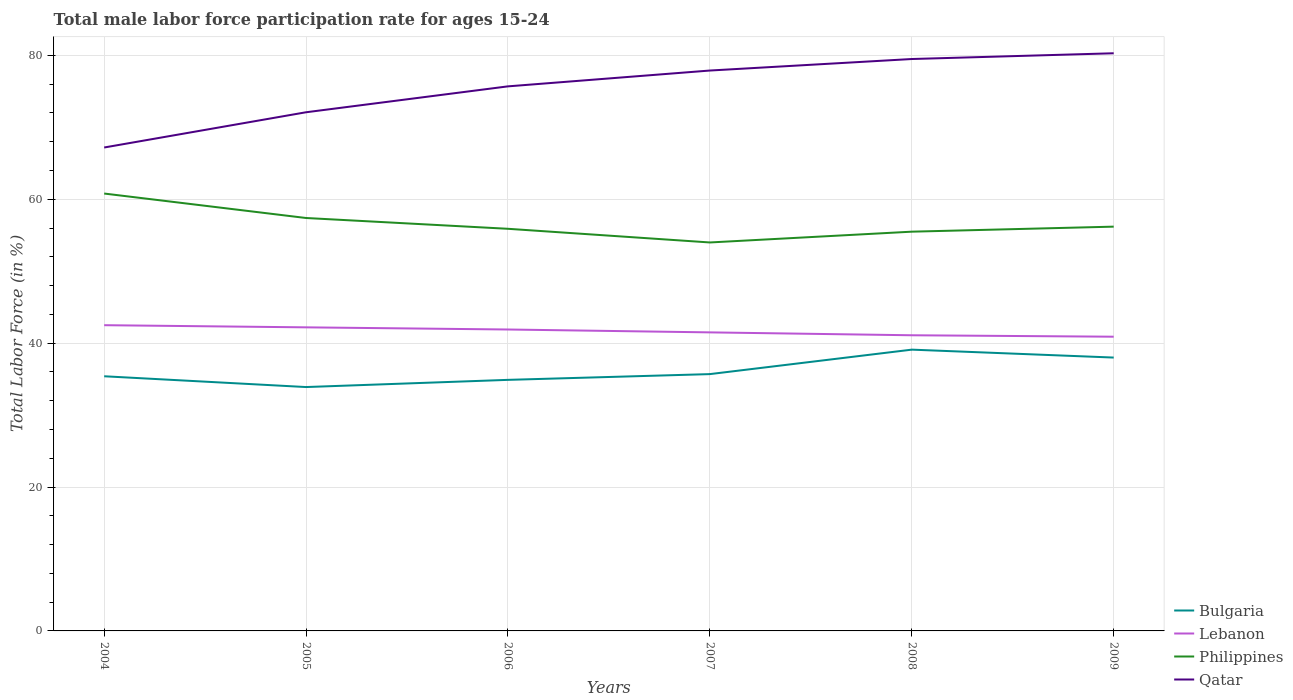Is the number of lines equal to the number of legend labels?
Ensure brevity in your answer.  Yes. Across all years, what is the maximum male labor force participation rate in Lebanon?
Provide a succinct answer. 40.9. In which year was the male labor force participation rate in Philippines maximum?
Give a very brief answer. 2007. What is the total male labor force participation rate in Lebanon in the graph?
Offer a terse response. 1.6. What is the difference between the highest and the second highest male labor force participation rate in Bulgaria?
Offer a very short reply. 5.2. How many years are there in the graph?
Your response must be concise. 6. Does the graph contain grids?
Your answer should be very brief. Yes. Where does the legend appear in the graph?
Provide a short and direct response. Bottom right. How many legend labels are there?
Make the answer very short. 4. What is the title of the graph?
Provide a succinct answer. Total male labor force participation rate for ages 15-24. What is the label or title of the X-axis?
Your answer should be very brief. Years. What is the label or title of the Y-axis?
Provide a succinct answer. Total Labor Force (in %). What is the Total Labor Force (in %) of Bulgaria in 2004?
Offer a terse response. 35.4. What is the Total Labor Force (in %) of Lebanon in 2004?
Ensure brevity in your answer.  42.5. What is the Total Labor Force (in %) in Philippines in 2004?
Offer a terse response. 60.8. What is the Total Labor Force (in %) of Qatar in 2004?
Offer a very short reply. 67.2. What is the Total Labor Force (in %) in Bulgaria in 2005?
Give a very brief answer. 33.9. What is the Total Labor Force (in %) in Lebanon in 2005?
Your answer should be compact. 42.2. What is the Total Labor Force (in %) in Philippines in 2005?
Make the answer very short. 57.4. What is the Total Labor Force (in %) of Qatar in 2005?
Ensure brevity in your answer.  72.1. What is the Total Labor Force (in %) in Bulgaria in 2006?
Offer a terse response. 34.9. What is the Total Labor Force (in %) in Lebanon in 2006?
Provide a succinct answer. 41.9. What is the Total Labor Force (in %) in Philippines in 2006?
Keep it short and to the point. 55.9. What is the Total Labor Force (in %) in Qatar in 2006?
Give a very brief answer. 75.7. What is the Total Labor Force (in %) in Bulgaria in 2007?
Your answer should be very brief. 35.7. What is the Total Labor Force (in %) in Lebanon in 2007?
Provide a succinct answer. 41.5. What is the Total Labor Force (in %) of Qatar in 2007?
Provide a short and direct response. 77.9. What is the Total Labor Force (in %) in Bulgaria in 2008?
Offer a terse response. 39.1. What is the Total Labor Force (in %) of Lebanon in 2008?
Your answer should be very brief. 41.1. What is the Total Labor Force (in %) of Philippines in 2008?
Provide a short and direct response. 55.5. What is the Total Labor Force (in %) of Qatar in 2008?
Provide a short and direct response. 79.5. What is the Total Labor Force (in %) of Bulgaria in 2009?
Ensure brevity in your answer.  38. What is the Total Labor Force (in %) of Lebanon in 2009?
Provide a short and direct response. 40.9. What is the Total Labor Force (in %) of Philippines in 2009?
Make the answer very short. 56.2. What is the Total Labor Force (in %) in Qatar in 2009?
Your response must be concise. 80.3. Across all years, what is the maximum Total Labor Force (in %) of Bulgaria?
Provide a succinct answer. 39.1. Across all years, what is the maximum Total Labor Force (in %) in Lebanon?
Provide a succinct answer. 42.5. Across all years, what is the maximum Total Labor Force (in %) of Philippines?
Your response must be concise. 60.8. Across all years, what is the maximum Total Labor Force (in %) of Qatar?
Give a very brief answer. 80.3. Across all years, what is the minimum Total Labor Force (in %) of Bulgaria?
Keep it short and to the point. 33.9. Across all years, what is the minimum Total Labor Force (in %) in Lebanon?
Ensure brevity in your answer.  40.9. Across all years, what is the minimum Total Labor Force (in %) of Qatar?
Keep it short and to the point. 67.2. What is the total Total Labor Force (in %) in Bulgaria in the graph?
Provide a succinct answer. 217. What is the total Total Labor Force (in %) of Lebanon in the graph?
Offer a very short reply. 250.1. What is the total Total Labor Force (in %) of Philippines in the graph?
Offer a terse response. 339.8. What is the total Total Labor Force (in %) in Qatar in the graph?
Give a very brief answer. 452.7. What is the difference between the Total Labor Force (in %) of Bulgaria in 2004 and that in 2005?
Give a very brief answer. 1.5. What is the difference between the Total Labor Force (in %) in Philippines in 2004 and that in 2005?
Offer a very short reply. 3.4. What is the difference between the Total Labor Force (in %) in Bulgaria in 2004 and that in 2006?
Provide a succinct answer. 0.5. What is the difference between the Total Labor Force (in %) in Lebanon in 2004 and that in 2006?
Your answer should be compact. 0.6. What is the difference between the Total Labor Force (in %) of Philippines in 2004 and that in 2006?
Your answer should be very brief. 4.9. What is the difference between the Total Labor Force (in %) in Lebanon in 2004 and that in 2007?
Provide a short and direct response. 1. What is the difference between the Total Labor Force (in %) of Philippines in 2004 and that in 2007?
Make the answer very short. 6.8. What is the difference between the Total Labor Force (in %) of Lebanon in 2004 and that in 2008?
Provide a succinct answer. 1.4. What is the difference between the Total Labor Force (in %) in Qatar in 2004 and that in 2008?
Ensure brevity in your answer.  -12.3. What is the difference between the Total Labor Force (in %) in Bulgaria in 2004 and that in 2009?
Your answer should be compact. -2.6. What is the difference between the Total Labor Force (in %) of Bulgaria in 2005 and that in 2006?
Keep it short and to the point. -1. What is the difference between the Total Labor Force (in %) of Qatar in 2005 and that in 2006?
Give a very brief answer. -3.6. What is the difference between the Total Labor Force (in %) in Bulgaria in 2005 and that in 2007?
Make the answer very short. -1.8. What is the difference between the Total Labor Force (in %) in Lebanon in 2005 and that in 2007?
Your response must be concise. 0.7. What is the difference between the Total Labor Force (in %) of Philippines in 2005 and that in 2007?
Your answer should be compact. 3.4. What is the difference between the Total Labor Force (in %) of Lebanon in 2005 and that in 2008?
Keep it short and to the point. 1.1. What is the difference between the Total Labor Force (in %) in Philippines in 2005 and that in 2008?
Keep it short and to the point. 1.9. What is the difference between the Total Labor Force (in %) of Philippines in 2005 and that in 2009?
Your response must be concise. 1.2. What is the difference between the Total Labor Force (in %) of Qatar in 2005 and that in 2009?
Make the answer very short. -8.2. What is the difference between the Total Labor Force (in %) of Bulgaria in 2006 and that in 2007?
Offer a very short reply. -0.8. What is the difference between the Total Labor Force (in %) of Philippines in 2006 and that in 2008?
Your answer should be very brief. 0.4. What is the difference between the Total Labor Force (in %) of Qatar in 2006 and that in 2008?
Give a very brief answer. -3.8. What is the difference between the Total Labor Force (in %) of Philippines in 2006 and that in 2009?
Your response must be concise. -0.3. What is the difference between the Total Labor Force (in %) in Qatar in 2006 and that in 2009?
Offer a terse response. -4.6. What is the difference between the Total Labor Force (in %) in Bulgaria in 2007 and that in 2008?
Provide a short and direct response. -3.4. What is the difference between the Total Labor Force (in %) in Lebanon in 2007 and that in 2008?
Make the answer very short. 0.4. What is the difference between the Total Labor Force (in %) in Bulgaria in 2007 and that in 2009?
Provide a short and direct response. -2.3. What is the difference between the Total Labor Force (in %) in Lebanon in 2007 and that in 2009?
Keep it short and to the point. 0.6. What is the difference between the Total Labor Force (in %) of Philippines in 2007 and that in 2009?
Give a very brief answer. -2.2. What is the difference between the Total Labor Force (in %) of Bulgaria in 2008 and that in 2009?
Make the answer very short. 1.1. What is the difference between the Total Labor Force (in %) in Philippines in 2008 and that in 2009?
Your answer should be compact. -0.7. What is the difference between the Total Labor Force (in %) in Bulgaria in 2004 and the Total Labor Force (in %) in Qatar in 2005?
Give a very brief answer. -36.7. What is the difference between the Total Labor Force (in %) in Lebanon in 2004 and the Total Labor Force (in %) in Philippines in 2005?
Keep it short and to the point. -14.9. What is the difference between the Total Labor Force (in %) of Lebanon in 2004 and the Total Labor Force (in %) of Qatar in 2005?
Make the answer very short. -29.6. What is the difference between the Total Labor Force (in %) in Philippines in 2004 and the Total Labor Force (in %) in Qatar in 2005?
Make the answer very short. -11.3. What is the difference between the Total Labor Force (in %) of Bulgaria in 2004 and the Total Labor Force (in %) of Philippines in 2006?
Your answer should be very brief. -20.5. What is the difference between the Total Labor Force (in %) in Bulgaria in 2004 and the Total Labor Force (in %) in Qatar in 2006?
Make the answer very short. -40.3. What is the difference between the Total Labor Force (in %) in Lebanon in 2004 and the Total Labor Force (in %) in Philippines in 2006?
Offer a very short reply. -13.4. What is the difference between the Total Labor Force (in %) of Lebanon in 2004 and the Total Labor Force (in %) of Qatar in 2006?
Provide a succinct answer. -33.2. What is the difference between the Total Labor Force (in %) of Philippines in 2004 and the Total Labor Force (in %) of Qatar in 2006?
Provide a short and direct response. -14.9. What is the difference between the Total Labor Force (in %) in Bulgaria in 2004 and the Total Labor Force (in %) in Philippines in 2007?
Keep it short and to the point. -18.6. What is the difference between the Total Labor Force (in %) of Bulgaria in 2004 and the Total Labor Force (in %) of Qatar in 2007?
Offer a very short reply. -42.5. What is the difference between the Total Labor Force (in %) in Lebanon in 2004 and the Total Labor Force (in %) in Philippines in 2007?
Offer a terse response. -11.5. What is the difference between the Total Labor Force (in %) of Lebanon in 2004 and the Total Labor Force (in %) of Qatar in 2007?
Offer a terse response. -35.4. What is the difference between the Total Labor Force (in %) of Philippines in 2004 and the Total Labor Force (in %) of Qatar in 2007?
Ensure brevity in your answer.  -17.1. What is the difference between the Total Labor Force (in %) of Bulgaria in 2004 and the Total Labor Force (in %) of Lebanon in 2008?
Offer a terse response. -5.7. What is the difference between the Total Labor Force (in %) in Bulgaria in 2004 and the Total Labor Force (in %) in Philippines in 2008?
Your answer should be compact. -20.1. What is the difference between the Total Labor Force (in %) of Bulgaria in 2004 and the Total Labor Force (in %) of Qatar in 2008?
Provide a succinct answer. -44.1. What is the difference between the Total Labor Force (in %) in Lebanon in 2004 and the Total Labor Force (in %) in Qatar in 2008?
Give a very brief answer. -37. What is the difference between the Total Labor Force (in %) in Philippines in 2004 and the Total Labor Force (in %) in Qatar in 2008?
Keep it short and to the point. -18.7. What is the difference between the Total Labor Force (in %) of Bulgaria in 2004 and the Total Labor Force (in %) of Lebanon in 2009?
Make the answer very short. -5.5. What is the difference between the Total Labor Force (in %) of Bulgaria in 2004 and the Total Labor Force (in %) of Philippines in 2009?
Make the answer very short. -20.8. What is the difference between the Total Labor Force (in %) of Bulgaria in 2004 and the Total Labor Force (in %) of Qatar in 2009?
Provide a succinct answer. -44.9. What is the difference between the Total Labor Force (in %) in Lebanon in 2004 and the Total Labor Force (in %) in Philippines in 2009?
Provide a succinct answer. -13.7. What is the difference between the Total Labor Force (in %) in Lebanon in 2004 and the Total Labor Force (in %) in Qatar in 2009?
Provide a succinct answer. -37.8. What is the difference between the Total Labor Force (in %) of Philippines in 2004 and the Total Labor Force (in %) of Qatar in 2009?
Offer a terse response. -19.5. What is the difference between the Total Labor Force (in %) in Bulgaria in 2005 and the Total Labor Force (in %) in Lebanon in 2006?
Offer a very short reply. -8. What is the difference between the Total Labor Force (in %) in Bulgaria in 2005 and the Total Labor Force (in %) in Philippines in 2006?
Your response must be concise. -22. What is the difference between the Total Labor Force (in %) in Bulgaria in 2005 and the Total Labor Force (in %) in Qatar in 2006?
Your answer should be very brief. -41.8. What is the difference between the Total Labor Force (in %) of Lebanon in 2005 and the Total Labor Force (in %) of Philippines in 2006?
Offer a very short reply. -13.7. What is the difference between the Total Labor Force (in %) in Lebanon in 2005 and the Total Labor Force (in %) in Qatar in 2006?
Provide a succinct answer. -33.5. What is the difference between the Total Labor Force (in %) of Philippines in 2005 and the Total Labor Force (in %) of Qatar in 2006?
Offer a terse response. -18.3. What is the difference between the Total Labor Force (in %) of Bulgaria in 2005 and the Total Labor Force (in %) of Philippines in 2007?
Give a very brief answer. -20.1. What is the difference between the Total Labor Force (in %) of Bulgaria in 2005 and the Total Labor Force (in %) of Qatar in 2007?
Ensure brevity in your answer.  -44. What is the difference between the Total Labor Force (in %) of Lebanon in 2005 and the Total Labor Force (in %) of Qatar in 2007?
Make the answer very short. -35.7. What is the difference between the Total Labor Force (in %) of Philippines in 2005 and the Total Labor Force (in %) of Qatar in 2007?
Offer a very short reply. -20.5. What is the difference between the Total Labor Force (in %) in Bulgaria in 2005 and the Total Labor Force (in %) in Lebanon in 2008?
Ensure brevity in your answer.  -7.2. What is the difference between the Total Labor Force (in %) in Bulgaria in 2005 and the Total Labor Force (in %) in Philippines in 2008?
Give a very brief answer. -21.6. What is the difference between the Total Labor Force (in %) of Bulgaria in 2005 and the Total Labor Force (in %) of Qatar in 2008?
Provide a short and direct response. -45.6. What is the difference between the Total Labor Force (in %) in Lebanon in 2005 and the Total Labor Force (in %) in Philippines in 2008?
Offer a terse response. -13.3. What is the difference between the Total Labor Force (in %) of Lebanon in 2005 and the Total Labor Force (in %) of Qatar in 2008?
Provide a short and direct response. -37.3. What is the difference between the Total Labor Force (in %) in Philippines in 2005 and the Total Labor Force (in %) in Qatar in 2008?
Provide a succinct answer. -22.1. What is the difference between the Total Labor Force (in %) in Bulgaria in 2005 and the Total Labor Force (in %) in Philippines in 2009?
Make the answer very short. -22.3. What is the difference between the Total Labor Force (in %) of Bulgaria in 2005 and the Total Labor Force (in %) of Qatar in 2009?
Provide a succinct answer. -46.4. What is the difference between the Total Labor Force (in %) in Lebanon in 2005 and the Total Labor Force (in %) in Qatar in 2009?
Offer a very short reply. -38.1. What is the difference between the Total Labor Force (in %) in Philippines in 2005 and the Total Labor Force (in %) in Qatar in 2009?
Offer a very short reply. -22.9. What is the difference between the Total Labor Force (in %) of Bulgaria in 2006 and the Total Labor Force (in %) of Lebanon in 2007?
Your response must be concise. -6.6. What is the difference between the Total Labor Force (in %) of Bulgaria in 2006 and the Total Labor Force (in %) of Philippines in 2007?
Offer a very short reply. -19.1. What is the difference between the Total Labor Force (in %) of Bulgaria in 2006 and the Total Labor Force (in %) of Qatar in 2007?
Your answer should be compact. -43. What is the difference between the Total Labor Force (in %) of Lebanon in 2006 and the Total Labor Force (in %) of Qatar in 2007?
Provide a short and direct response. -36. What is the difference between the Total Labor Force (in %) in Philippines in 2006 and the Total Labor Force (in %) in Qatar in 2007?
Your answer should be compact. -22. What is the difference between the Total Labor Force (in %) in Bulgaria in 2006 and the Total Labor Force (in %) in Philippines in 2008?
Offer a very short reply. -20.6. What is the difference between the Total Labor Force (in %) in Bulgaria in 2006 and the Total Labor Force (in %) in Qatar in 2008?
Provide a succinct answer. -44.6. What is the difference between the Total Labor Force (in %) in Lebanon in 2006 and the Total Labor Force (in %) in Philippines in 2008?
Keep it short and to the point. -13.6. What is the difference between the Total Labor Force (in %) of Lebanon in 2006 and the Total Labor Force (in %) of Qatar in 2008?
Your response must be concise. -37.6. What is the difference between the Total Labor Force (in %) in Philippines in 2006 and the Total Labor Force (in %) in Qatar in 2008?
Keep it short and to the point. -23.6. What is the difference between the Total Labor Force (in %) of Bulgaria in 2006 and the Total Labor Force (in %) of Lebanon in 2009?
Offer a very short reply. -6. What is the difference between the Total Labor Force (in %) in Bulgaria in 2006 and the Total Labor Force (in %) in Philippines in 2009?
Your answer should be compact. -21.3. What is the difference between the Total Labor Force (in %) in Bulgaria in 2006 and the Total Labor Force (in %) in Qatar in 2009?
Your answer should be compact. -45.4. What is the difference between the Total Labor Force (in %) of Lebanon in 2006 and the Total Labor Force (in %) of Philippines in 2009?
Offer a very short reply. -14.3. What is the difference between the Total Labor Force (in %) in Lebanon in 2006 and the Total Labor Force (in %) in Qatar in 2009?
Offer a very short reply. -38.4. What is the difference between the Total Labor Force (in %) in Philippines in 2006 and the Total Labor Force (in %) in Qatar in 2009?
Provide a short and direct response. -24.4. What is the difference between the Total Labor Force (in %) in Bulgaria in 2007 and the Total Labor Force (in %) in Philippines in 2008?
Ensure brevity in your answer.  -19.8. What is the difference between the Total Labor Force (in %) in Bulgaria in 2007 and the Total Labor Force (in %) in Qatar in 2008?
Your response must be concise. -43.8. What is the difference between the Total Labor Force (in %) in Lebanon in 2007 and the Total Labor Force (in %) in Philippines in 2008?
Make the answer very short. -14. What is the difference between the Total Labor Force (in %) in Lebanon in 2007 and the Total Labor Force (in %) in Qatar in 2008?
Your answer should be compact. -38. What is the difference between the Total Labor Force (in %) in Philippines in 2007 and the Total Labor Force (in %) in Qatar in 2008?
Provide a short and direct response. -25.5. What is the difference between the Total Labor Force (in %) of Bulgaria in 2007 and the Total Labor Force (in %) of Lebanon in 2009?
Provide a succinct answer. -5.2. What is the difference between the Total Labor Force (in %) of Bulgaria in 2007 and the Total Labor Force (in %) of Philippines in 2009?
Your response must be concise. -20.5. What is the difference between the Total Labor Force (in %) in Bulgaria in 2007 and the Total Labor Force (in %) in Qatar in 2009?
Offer a very short reply. -44.6. What is the difference between the Total Labor Force (in %) of Lebanon in 2007 and the Total Labor Force (in %) of Philippines in 2009?
Your response must be concise. -14.7. What is the difference between the Total Labor Force (in %) in Lebanon in 2007 and the Total Labor Force (in %) in Qatar in 2009?
Provide a succinct answer. -38.8. What is the difference between the Total Labor Force (in %) of Philippines in 2007 and the Total Labor Force (in %) of Qatar in 2009?
Keep it short and to the point. -26.3. What is the difference between the Total Labor Force (in %) of Bulgaria in 2008 and the Total Labor Force (in %) of Philippines in 2009?
Your answer should be very brief. -17.1. What is the difference between the Total Labor Force (in %) in Bulgaria in 2008 and the Total Labor Force (in %) in Qatar in 2009?
Make the answer very short. -41.2. What is the difference between the Total Labor Force (in %) of Lebanon in 2008 and the Total Labor Force (in %) of Philippines in 2009?
Offer a terse response. -15.1. What is the difference between the Total Labor Force (in %) in Lebanon in 2008 and the Total Labor Force (in %) in Qatar in 2009?
Offer a terse response. -39.2. What is the difference between the Total Labor Force (in %) of Philippines in 2008 and the Total Labor Force (in %) of Qatar in 2009?
Offer a very short reply. -24.8. What is the average Total Labor Force (in %) of Bulgaria per year?
Ensure brevity in your answer.  36.17. What is the average Total Labor Force (in %) in Lebanon per year?
Offer a very short reply. 41.68. What is the average Total Labor Force (in %) in Philippines per year?
Offer a terse response. 56.63. What is the average Total Labor Force (in %) in Qatar per year?
Offer a terse response. 75.45. In the year 2004, what is the difference between the Total Labor Force (in %) in Bulgaria and Total Labor Force (in %) in Lebanon?
Make the answer very short. -7.1. In the year 2004, what is the difference between the Total Labor Force (in %) in Bulgaria and Total Labor Force (in %) in Philippines?
Keep it short and to the point. -25.4. In the year 2004, what is the difference between the Total Labor Force (in %) of Bulgaria and Total Labor Force (in %) of Qatar?
Offer a very short reply. -31.8. In the year 2004, what is the difference between the Total Labor Force (in %) of Lebanon and Total Labor Force (in %) of Philippines?
Make the answer very short. -18.3. In the year 2004, what is the difference between the Total Labor Force (in %) of Lebanon and Total Labor Force (in %) of Qatar?
Provide a short and direct response. -24.7. In the year 2004, what is the difference between the Total Labor Force (in %) in Philippines and Total Labor Force (in %) in Qatar?
Your answer should be very brief. -6.4. In the year 2005, what is the difference between the Total Labor Force (in %) in Bulgaria and Total Labor Force (in %) in Philippines?
Provide a succinct answer. -23.5. In the year 2005, what is the difference between the Total Labor Force (in %) in Bulgaria and Total Labor Force (in %) in Qatar?
Your answer should be compact. -38.2. In the year 2005, what is the difference between the Total Labor Force (in %) of Lebanon and Total Labor Force (in %) of Philippines?
Give a very brief answer. -15.2. In the year 2005, what is the difference between the Total Labor Force (in %) of Lebanon and Total Labor Force (in %) of Qatar?
Your answer should be very brief. -29.9. In the year 2005, what is the difference between the Total Labor Force (in %) of Philippines and Total Labor Force (in %) of Qatar?
Keep it short and to the point. -14.7. In the year 2006, what is the difference between the Total Labor Force (in %) in Bulgaria and Total Labor Force (in %) in Qatar?
Your response must be concise. -40.8. In the year 2006, what is the difference between the Total Labor Force (in %) of Lebanon and Total Labor Force (in %) of Qatar?
Provide a succinct answer. -33.8. In the year 2006, what is the difference between the Total Labor Force (in %) of Philippines and Total Labor Force (in %) of Qatar?
Provide a short and direct response. -19.8. In the year 2007, what is the difference between the Total Labor Force (in %) of Bulgaria and Total Labor Force (in %) of Philippines?
Keep it short and to the point. -18.3. In the year 2007, what is the difference between the Total Labor Force (in %) of Bulgaria and Total Labor Force (in %) of Qatar?
Ensure brevity in your answer.  -42.2. In the year 2007, what is the difference between the Total Labor Force (in %) in Lebanon and Total Labor Force (in %) in Philippines?
Your answer should be compact. -12.5. In the year 2007, what is the difference between the Total Labor Force (in %) in Lebanon and Total Labor Force (in %) in Qatar?
Give a very brief answer. -36.4. In the year 2007, what is the difference between the Total Labor Force (in %) in Philippines and Total Labor Force (in %) in Qatar?
Make the answer very short. -23.9. In the year 2008, what is the difference between the Total Labor Force (in %) in Bulgaria and Total Labor Force (in %) in Philippines?
Offer a very short reply. -16.4. In the year 2008, what is the difference between the Total Labor Force (in %) in Bulgaria and Total Labor Force (in %) in Qatar?
Your answer should be very brief. -40.4. In the year 2008, what is the difference between the Total Labor Force (in %) in Lebanon and Total Labor Force (in %) in Philippines?
Ensure brevity in your answer.  -14.4. In the year 2008, what is the difference between the Total Labor Force (in %) in Lebanon and Total Labor Force (in %) in Qatar?
Ensure brevity in your answer.  -38.4. In the year 2008, what is the difference between the Total Labor Force (in %) in Philippines and Total Labor Force (in %) in Qatar?
Offer a very short reply. -24. In the year 2009, what is the difference between the Total Labor Force (in %) of Bulgaria and Total Labor Force (in %) of Lebanon?
Keep it short and to the point. -2.9. In the year 2009, what is the difference between the Total Labor Force (in %) of Bulgaria and Total Labor Force (in %) of Philippines?
Provide a succinct answer. -18.2. In the year 2009, what is the difference between the Total Labor Force (in %) of Bulgaria and Total Labor Force (in %) of Qatar?
Offer a terse response. -42.3. In the year 2009, what is the difference between the Total Labor Force (in %) of Lebanon and Total Labor Force (in %) of Philippines?
Give a very brief answer. -15.3. In the year 2009, what is the difference between the Total Labor Force (in %) of Lebanon and Total Labor Force (in %) of Qatar?
Your answer should be very brief. -39.4. In the year 2009, what is the difference between the Total Labor Force (in %) of Philippines and Total Labor Force (in %) of Qatar?
Offer a very short reply. -24.1. What is the ratio of the Total Labor Force (in %) of Bulgaria in 2004 to that in 2005?
Offer a terse response. 1.04. What is the ratio of the Total Labor Force (in %) of Lebanon in 2004 to that in 2005?
Provide a succinct answer. 1.01. What is the ratio of the Total Labor Force (in %) in Philippines in 2004 to that in 2005?
Offer a very short reply. 1.06. What is the ratio of the Total Labor Force (in %) of Qatar in 2004 to that in 2005?
Your answer should be very brief. 0.93. What is the ratio of the Total Labor Force (in %) of Bulgaria in 2004 to that in 2006?
Provide a succinct answer. 1.01. What is the ratio of the Total Labor Force (in %) in Lebanon in 2004 to that in 2006?
Ensure brevity in your answer.  1.01. What is the ratio of the Total Labor Force (in %) of Philippines in 2004 to that in 2006?
Provide a succinct answer. 1.09. What is the ratio of the Total Labor Force (in %) of Qatar in 2004 to that in 2006?
Ensure brevity in your answer.  0.89. What is the ratio of the Total Labor Force (in %) of Lebanon in 2004 to that in 2007?
Ensure brevity in your answer.  1.02. What is the ratio of the Total Labor Force (in %) in Philippines in 2004 to that in 2007?
Offer a very short reply. 1.13. What is the ratio of the Total Labor Force (in %) of Qatar in 2004 to that in 2007?
Your response must be concise. 0.86. What is the ratio of the Total Labor Force (in %) of Bulgaria in 2004 to that in 2008?
Provide a short and direct response. 0.91. What is the ratio of the Total Labor Force (in %) of Lebanon in 2004 to that in 2008?
Offer a terse response. 1.03. What is the ratio of the Total Labor Force (in %) of Philippines in 2004 to that in 2008?
Provide a short and direct response. 1.1. What is the ratio of the Total Labor Force (in %) of Qatar in 2004 to that in 2008?
Keep it short and to the point. 0.85. What is the ratio of the Total Labor Force (in %) of Bulgaria in 2004 to that in 2009?
Give a very brief answer. 0.93. What is the ratio of the Total Labor Force (in %) of Lebanon in 2004 to that in 2009?
Give a very brief answer. 1.04. What is the ratio of the Total Labor Force (in %) in Philippines in 2004 to that in 2009?
Provide a succinct answer. 1.08. What is the ratio of the Total Labor Force (in %) of Qatar in 2004 to that in 2009?
Your response must be concise. 0.84. What is the ratio of the Total Labor Force (in %) in Bulgaria in 2005 to that in 2006?
Keep it short and to the point. 0.97. What is the ratio of the Total Labor Force (in %) of Lebanon in 2005 to that in 2006?
Your answer should be very brief. 1.01. What is the ratio of the Total Labor Force (in %) in Philippines in 2005 to that in 2006?
Provide a short and direct response. 1.03. What is the ratio of the Total Labor Force (in %) in Bulgaria in 2005 to that in 2007?
Your answer should be compact. 0.95. What is the ratio of the Total Labor Force (in %) in Lebanon in 2005 to that in 2007?
Give a very brief answer. 1.02. What is the ratio of the Total Labor Force (in %) of Philippines in 2005 to that in 2007?
Provide a short and direct response. 1.06. What is the ratio of the Total Labor Force (in %) in Qatar in 2005 to that in 2007?
Provide a short and direct response. 0.93. What is the ratio of the Total Labor Force (in %) in Bulgaria in 2005 to that in 2008?
Give a very brief answer. 0.87. What is the ratio of the Total Labor Force (in %) in Lebanon in 2005 to that in 2008?
Keep it short and to the point. 1.03. What is the ratio of the Total Labor Force (in %) in Philippines in 2005 to that in 2008?
Your answer should be very brief. 1.03. What is the ratio of the Total Labor Force (in %) in Qatar in 2005 to that in 2008?
Provide a succinct answer. 0.91. What is the ratio of the Total Labor Force (in %) in Bulgaria in 2005 to that in 2009?
Offer a terse response. 0.89. What is the ratio of the Total Labor Force (in %) of Lebanon in 2005 to that in 2009?
Provide a short and direct response. 1.03. What is the ratio of the Total Labor Force (in %) in Philippines in 2005 to that in 2009?
Offer a very short reply. 1.02. What is the ratio of the Total Labor Force (in %) in Qatar in 2005 to that in 2009?
Ensure brevity in your answer.  0.9. What is the ratio of the Total Labor Force (in %) of Bulgaria in 2006 to that in 2007?
Provide a succinct answer. 0.98. What is the ratio of the Total Labor Force (in %) of Lebanon in 2006 to that in 2007?
Your answer should be very brief. 1.01. What is the ratio of the Total Labor Force (in %) of Philippines in 2006 to that in 2007?
Your answer should be compact. 1.04. What is the ratio of the Total Labor Force (in %) in Qatar in 2006 to that in 2007?
Provide a short and direct response. 0.97. What is the ratio of the Total Labor Force (in %) of Bulgaria in 2006 to that in 2008?
Provide a succinct answer. 0.89. What is the ratio of the Total Labor Force (in %) in Lebanon in 2006 to that in 2008?
Offer a very short reply. 1.02. What is the ratio of the Total Labor Force (in %) in Qatar in 2006 to that in 2008?
Your answer should be compact. 0.95. What is the ratio of the Total Labor Force (in %) of Bulgaria in 2006 to that in 2009?
Provide a short and direct response. 0.92. What is the ratio of the Total Labor Force (in %) in Lebanon in 2006 to that in 2009?
Offer a very short reply. 1.02. What is the ratio of the Total Labor Force (in %) of Philippines in 2006 to that in 2009?
Provide a short and direct response. 0.99. What is the ratio of the Total Labor Force (in %) of Qatar in 2006 to that in 2009?
Make the answer very short. 0.94. What is the ratio of the Total Labor Force (in %) in Bulgaria in 2007 to that in 2008?
Your answer should be compact. 0.91. What is the ratio of the Total Labor Force (in %) in Lebanon in 2007 to that in 2008?
Ensure brevity in your answer.  1.01. What is the ratio of the Total Labor Force (in %) of Qatar in 2007 to that in 2008?
Give a very brief answer. 0.98. What is the ratio of the Total Labor Force (in %) in Bulgaria in 2007 to that in 2009?
Make the answer very short. 0.94. What is the ratio of the Total Labor Force (in %) of Lebanon in 2007 to that in 2009?
Your answer should be very brief. 1.01. What is the ratio of the Total Labor Force (in %) in Philippines in 2007 to that in 2009?
Keep it short and to the point. 0.96. What is the ratio of the Total Labor Force (in %) in Qatar in 2007 to that in 2009?
Offer a very short reply. 0.97. What is the ratio of the Total Labor Force (in %) of Bulgaria in 2008 to that in 2009?
Ensure brevity in your answer.  1.03. What is the ratio of the Total Labor Force (in %) in Lebanon in 2008 to that in 2009?
Offer a terse response. 1. What is the ratio of the Total Labor Force (in %) in Philippines in 2008 to that in 2009?
Provide a succinct answer. 0.99. What is the ratio of the Total Labor Force (in %) in Qatar in 2008 to that in 2009?
Give a very brief answer. 0.99. What is the difference between the highest and the second highest Total Labor Force (in %) in Bulgaria?
Offer a terse response. 1.1. What is the difference between the highest and the second highest Total Labor Force (in %) of Lebanon?
Make the answer very short. 0.3. What is the difference between the highest and the second highest Total Labor Force (in %) in Philippines?
Give a very brief answer. 3.4. What is the difference between the highest and the lowest Total Labor Force (in %) in Bulgaria?
Ensure brevity in your answer.  5.2. What is the difference between the highest and the lowest Total Labor Force (in %) of Qatar?
Offer a very short reply. 13.1. 